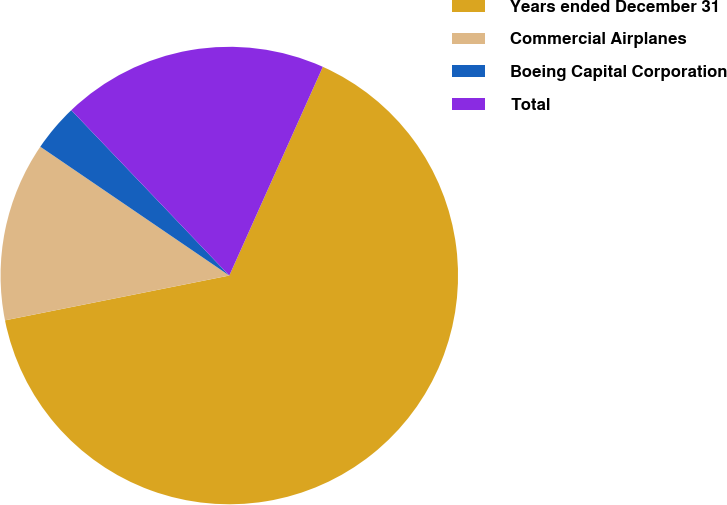<chart> <loc_0><loc_0><loc_500><loc_500><pie_chart><fcel>Years ended December 31<fcel>Commercial Airplanes<fcel>Boeing Capital Corporation<fcel>Total<nl><fcel>65.15%<fcel>12.66%<fcel>3.34%<fcel>18.84%<nl></chart> 